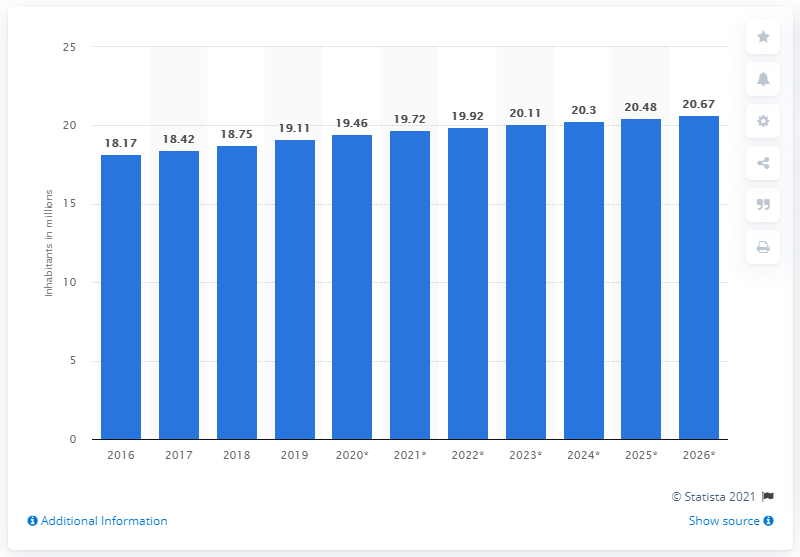Mention a couple of crucial points in this snapshot. Chile's population in 2019 was estimated to be 19.11 million people. 